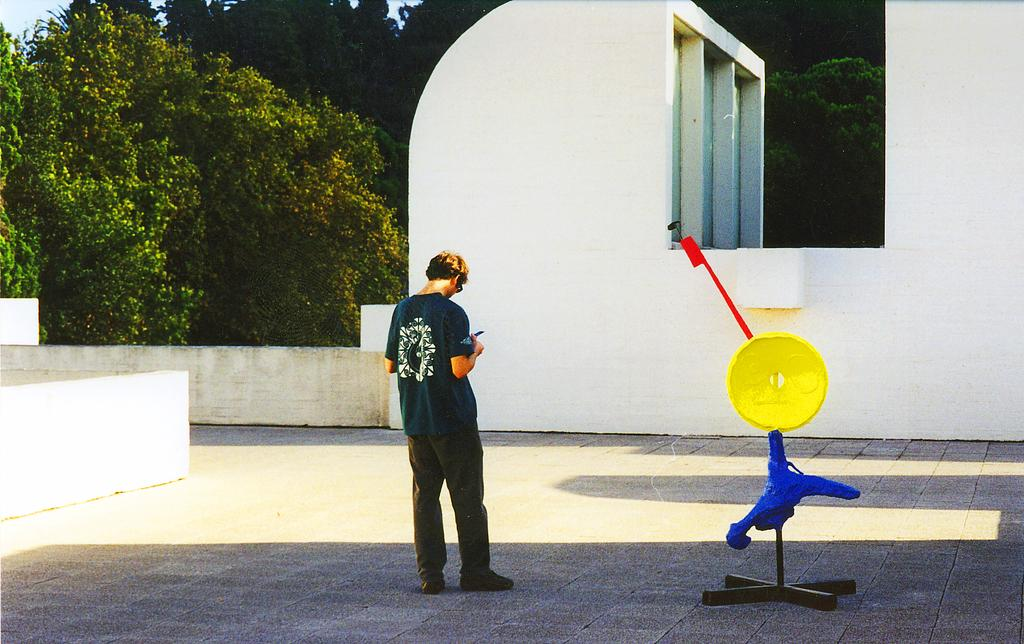What is the main subject in the image? There is a man standing in the image. What can be seen on the floor in the image? There is an object on a stand on the floor. What type of natural scenery is visible in the background of the image? There are trees in the background of the image. What else can be seen in the background of the image? There is a wall and the sky visible in the background of the image. What type of coal is being used to fuel the man's head in the image? There is no coal or indication of the man's head being fueled in the image. 